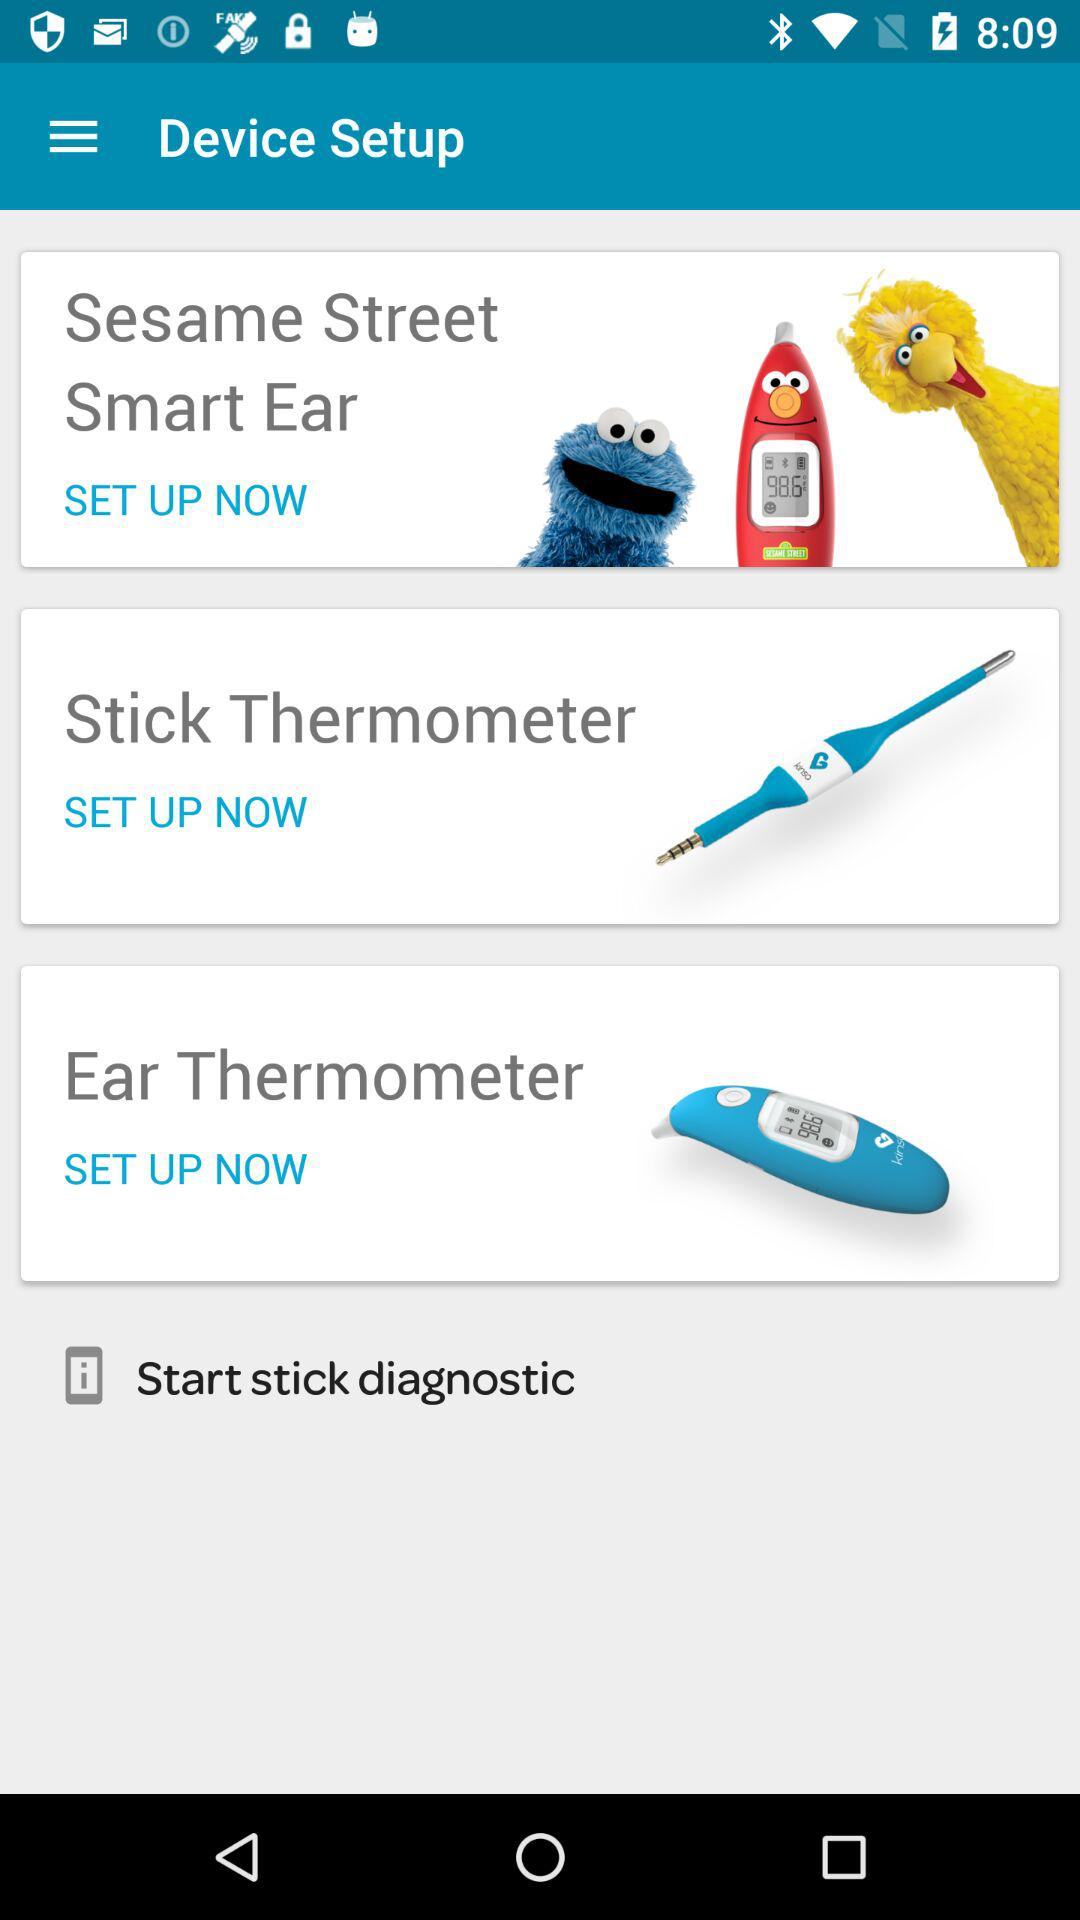How many thermometers are there in total?
Answer the question using a single word or phrase. 3 